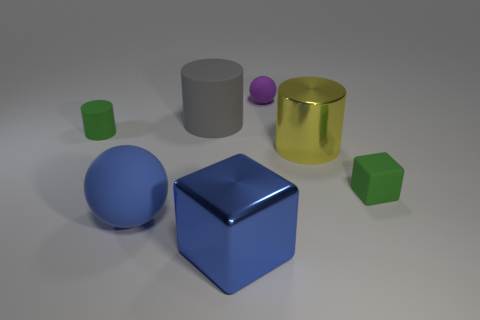Can you tell me the colors of the other objects in the picture? Certainly! In addition to the blue sphere, there's a large blue block, a gray cylinder, a translucent gold cylinder, a small green cube, and a tiny purple sphere. 